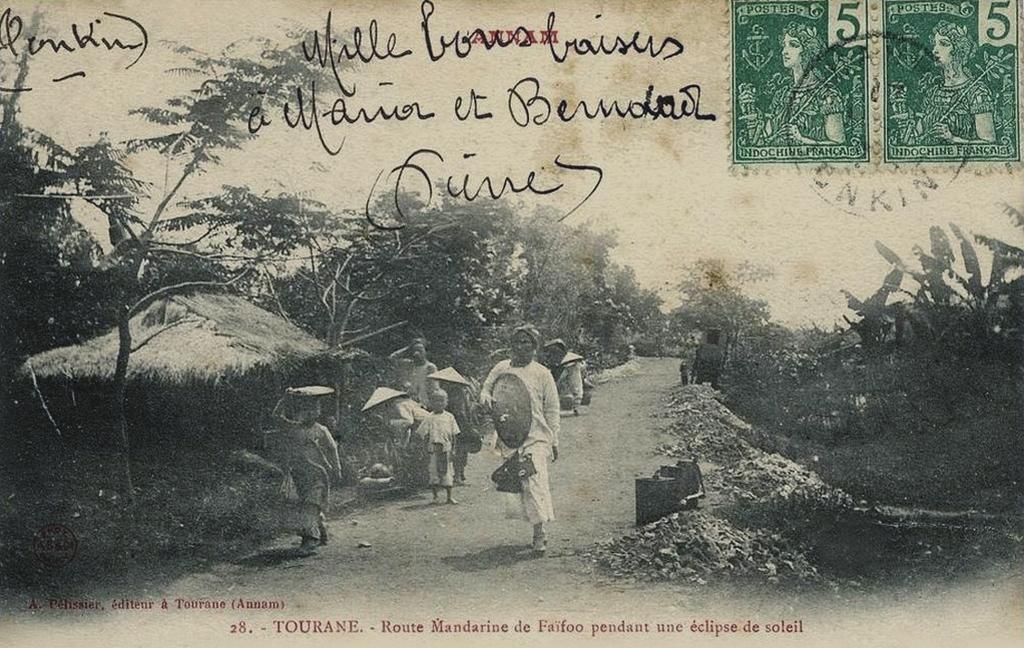Please provide a concise description of this image. As we can see in the image there is a paper. On paper there are huts, trees, plants, few people here and there and a sky. 